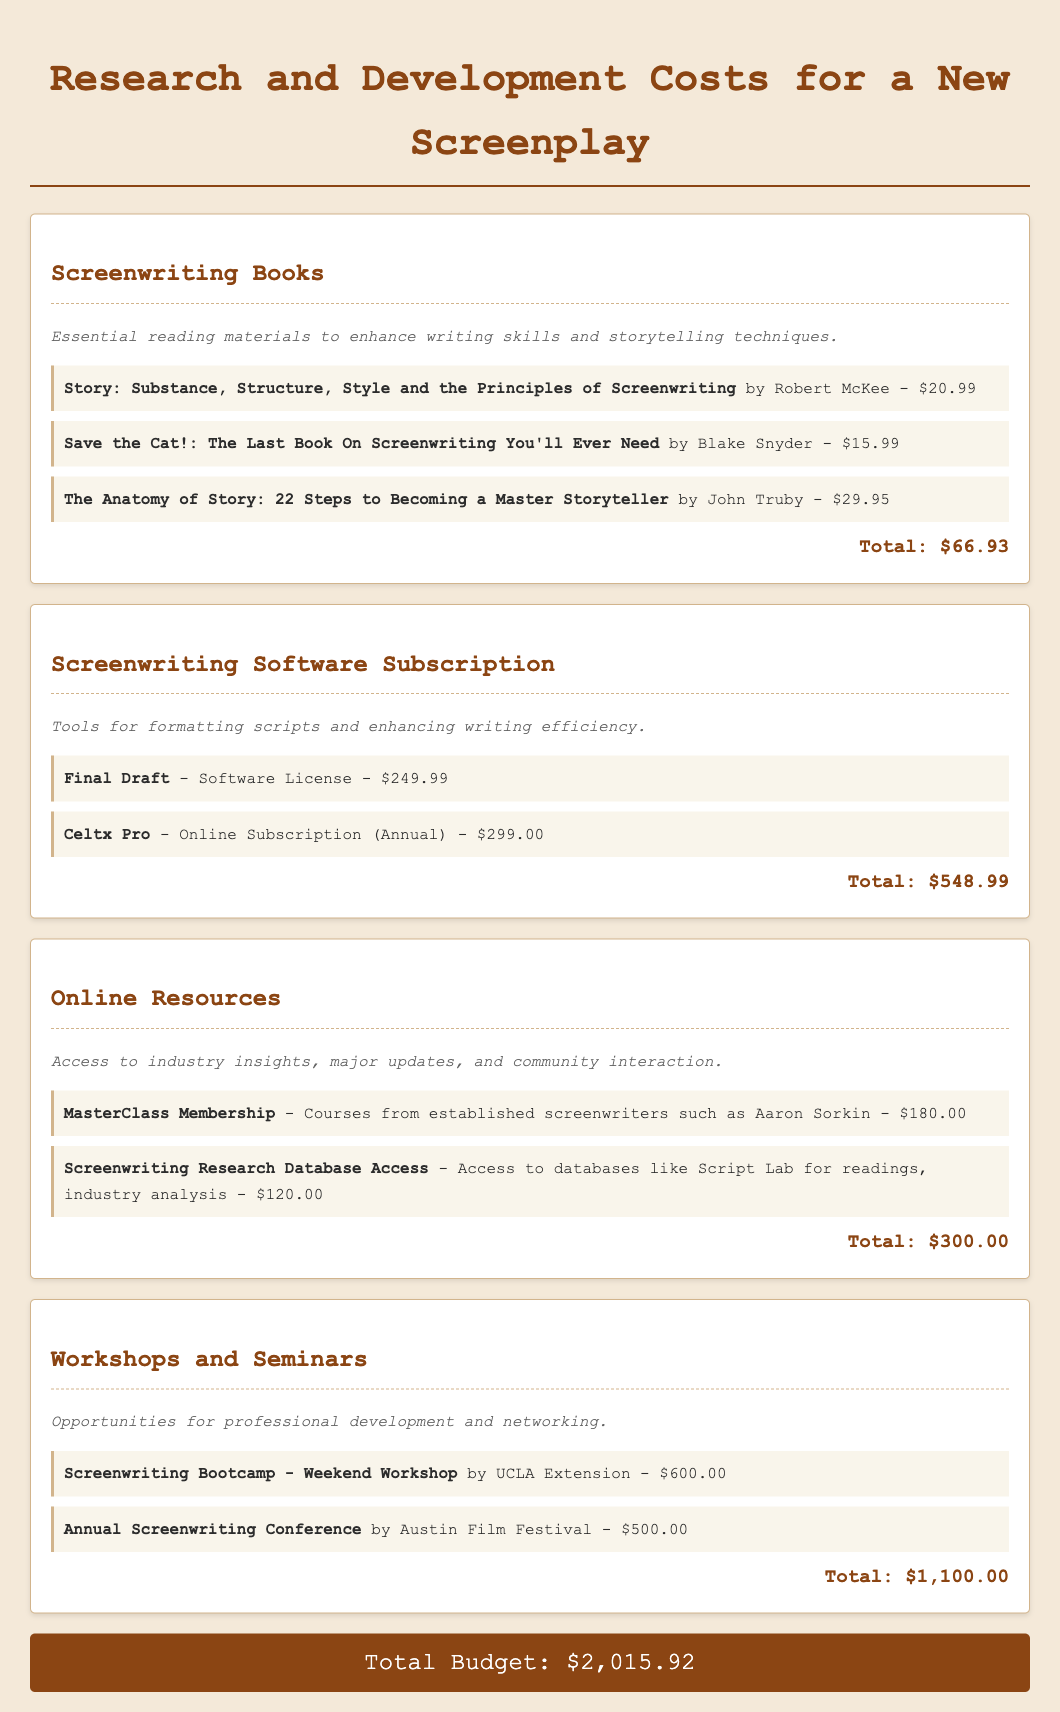What is the total cost of Screenwriting Books? The total cost is calculated based on the individual prices of the listed books in the document.
Answer: $66.93 How much does the Final Draft software license cost? The document states the specific cost of the Final Draft software license under the Screenwriting Software Subscription section.
Answer: $249.99 What is the price of the MasterClass Membership? The document lists the cost associated with the MasterClass Membership under Online Resources.
Answer: $180.00 What is the total budget for Workshops and Seminars? The total cost is derived from the listed prices for workshops and conferences mentioned in this section.
Answer: $1,100.00 How much do the online resources total? The total amount for the online resources is explicitly provided at the end of that budget item in the document.
Answer: $300.00 What are the two main categories listed in the budget? The budget includes various categories such as Screenwriting Books and Screenwriting Software Subscription.
Answer: Screenwriting Books, Screenwriting Software Subscription What is the grand total of the budget? The grand total is the sum of all budget items detailed in the document, presented at the end of the budget.
Answer: $2,015.92 What is the price of the Celtx Pro online subscription? The document specifies the annual price for the Celtx Pro online subscription under the Software Subscription category.
Answer: $299.00 